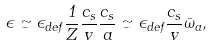<formula> <loc_0><loc_0><loc_500><loc_500>\epsilon \simeq \epsilon _ { d e f } \frac { 1 } { Z } \frac { c _ { s } } { v } \frac { c _ { s } } { a } \simeq \epsilon _ { d e f } \frac { c _ { s } } { v } { \bar { \omega } _ { a } } ,</formula> 